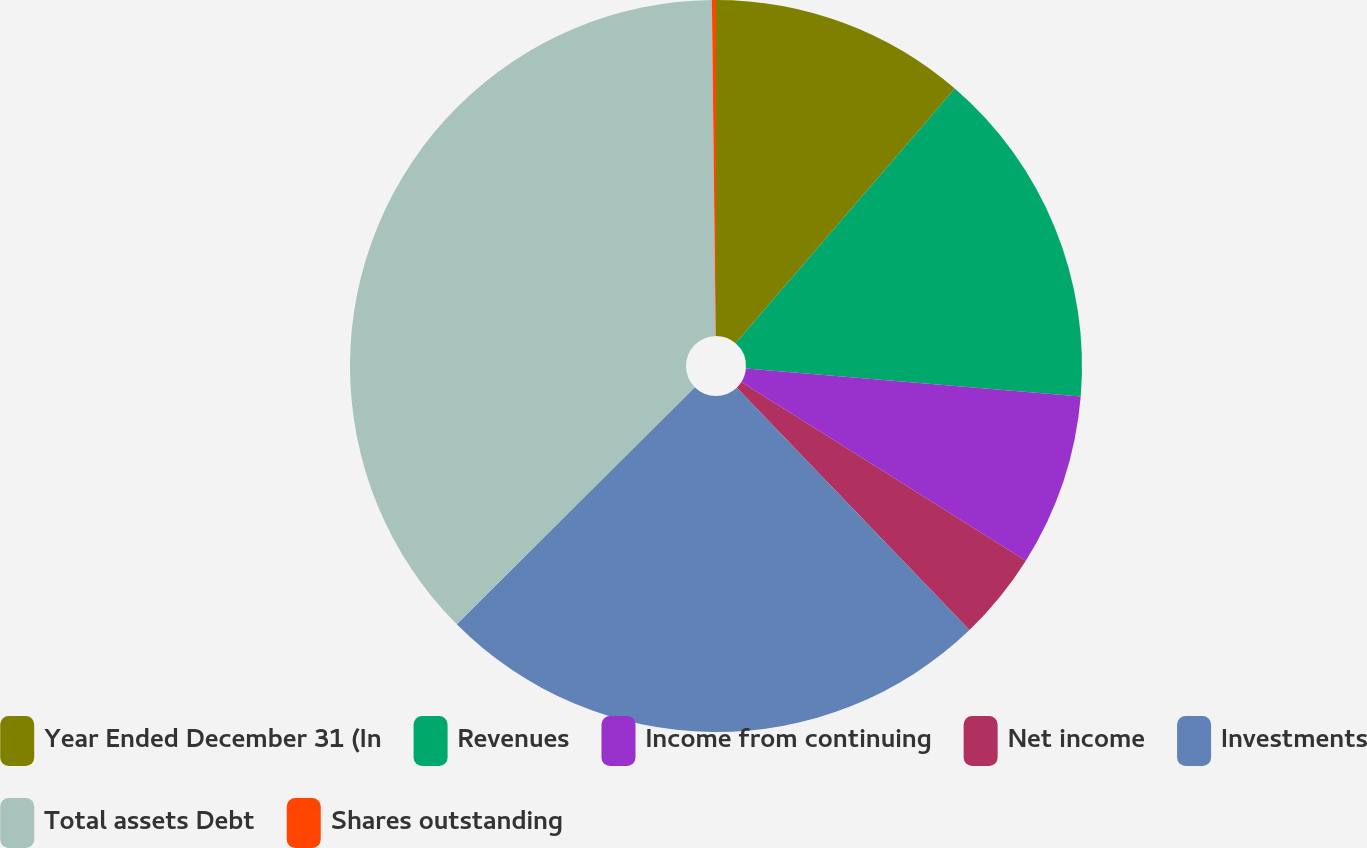Convert chart. <chart><loc_0><loc_0><loc_500><loc_500><pie_chart><fcel>Year Ended December 31 (In<fcel>Revenues<fcel>Income from continuing<fcel>Net income<fcel>Investments<fcel>Total assets Debt<fcel>Shares outstanding<nl><fcel>11.31%<fcel>15.02%<fcel>7.6%<fcel>3.89%<fcel>24.7%<fcel>37.29%<fcel>0.18%<nl></chart> 